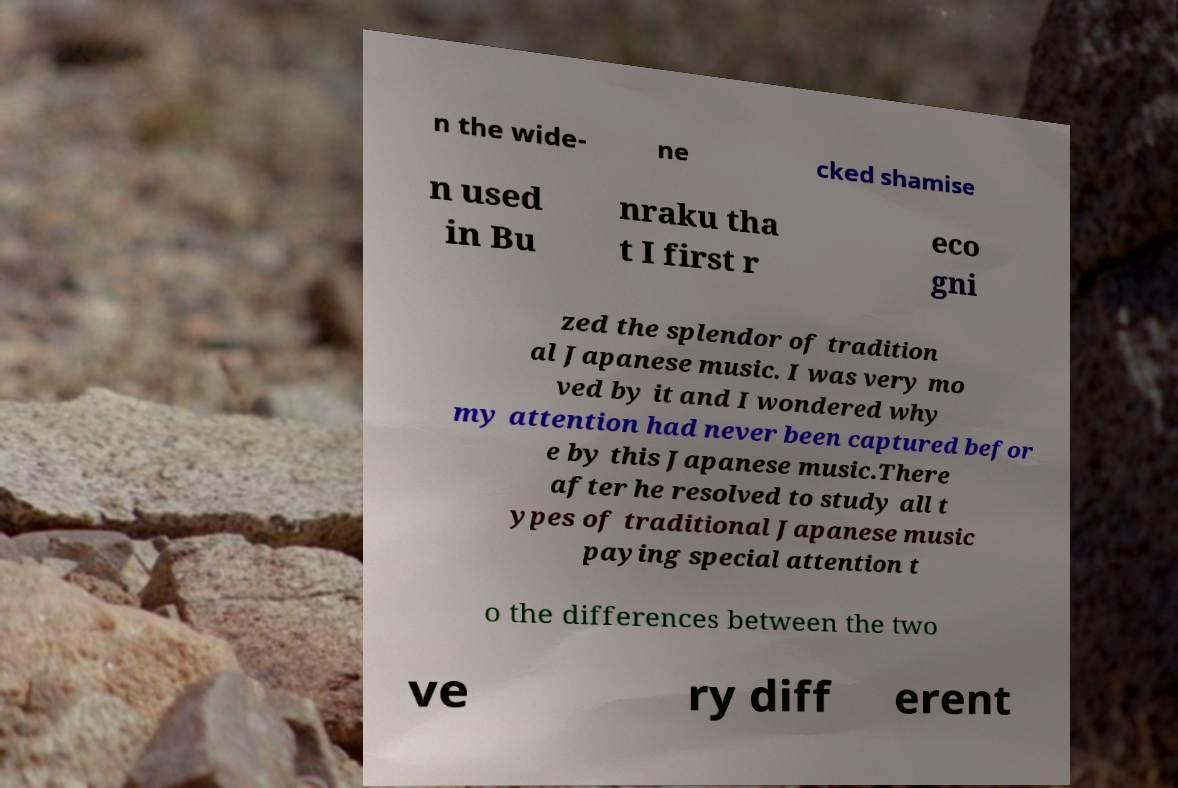Could you assist in decoding the text presented in this image and type it out clearly? n the wide- ne cked shamise n used in Bu nraku tha t I first r eco gni zed the splendor of tradition al Japanese music. I was very mo ved by it and I wondered why my attention had never been captured befor e by this Japanese music.There after he resolved to study all t ypes of traditional Japanese music paying special attention t o the differences between the two ve ry diff erent 